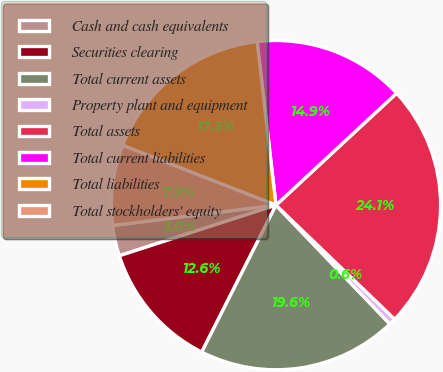Convert chart. <chart><loc_0><loc_0><loc_500><loc_500><pie_chart><fcel>Cash and cash equivalents<fcel>Securities clearing<fcel>Total current assets<fcel>Property plant and equipment<fcel>Total assets<fcel>Total current liabilities<fcel>Total liabilities<fcel>Total stockholders' equity<nl><fcel>3.0%<fcel>12.58%<fcel>19.61%<fcel>0.65%<fcel>24.09%<fcel>14.92%<fcel>17.26%<fcel>7.89%<nl></chart> 